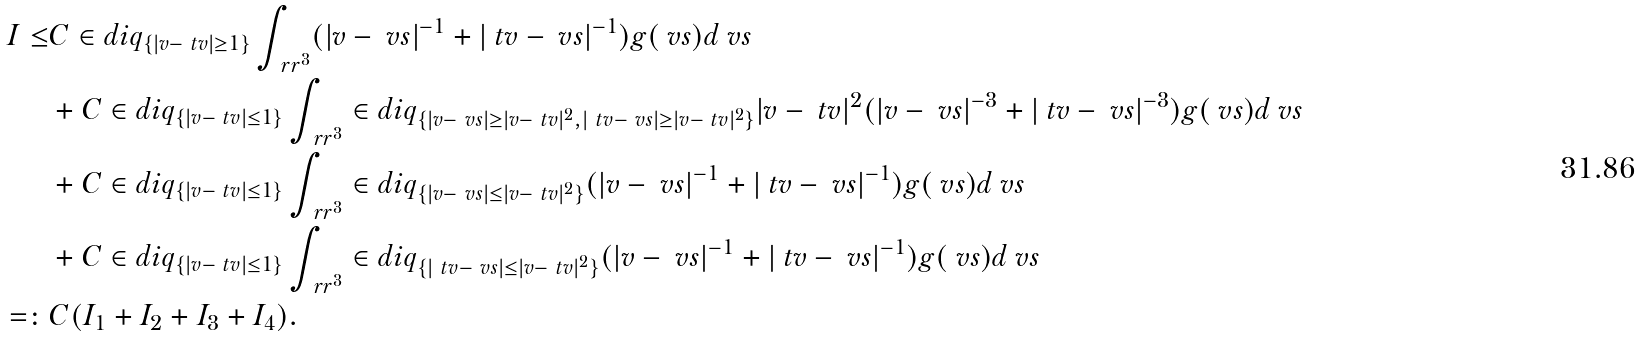Convert formula to latex. <formula><loc_0><loc_0><loc_500><loc_500>I \leq & C \in d i q _ { \{ | v - \ t v | \geq 1 \} } \int _ { \ r r ^ { 3 } } ( | v - \ v s | ^ { - 1 } + | \ t v - \ v s | ^ { - 1 } ) g ( \ v s ) d \ v s \\ & + C \in d i q _ { \{ | v - \ t v | \leq 1 \} } \int _ { \ r r ^ { 3 } } \in d i q _ { \{ | v - \ v s | \geq | v - \ t v | ^ { 2 } , | \ t v - \ v s | \geq | v - \ t v | ^ { 2 } \} } | v - \ t v | ^ { 2 } ( | v - \ v s | ^ { - 3 } + | \ t v - \ v s | ^ { - 3 } ) g ( \ v s ) d \ v s \\ & + C \in d i q _ { \{ | v - \ t v | \leq 1 \} } \int _ { \ r r ^ { 3 } } \in d i q _ { \{ | v - \ v s | \leq | v - \ t v | ^ { 2 } \} } ( | v - \ v s | ^ { - 1 } + | \ t v - \ v s | ^ { - 1 } ) g ( \ v s ) d \ v s \\ & + C \in d i q _ { \{ | v - \ t v | \leq 1 \} } \int _ { \ r r ^ { 3 } } \in d i q _ { \{ | \ t v - \ v s | \leq | v - \ t v | ^ { 2 } \} } ( | v - \ v s | ^ { - 1 } + | \ t v - \ v s | ^ { - 1 } ) g ( \ v s ) d \ v s \\ = \colon & C ( I _ { 1 } + I _ { 2 } + I _ { 3 } + I _ { 4 } ) .</formula> 